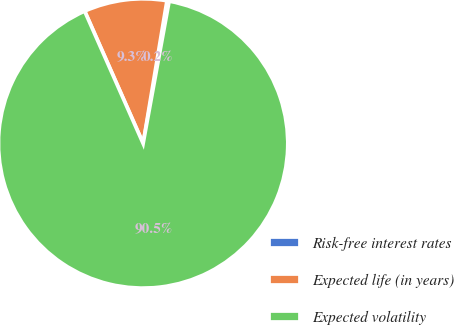Convert chart. <chart><loc_0><loc_0><loc_500><loc_500><pie_chart><fcel>Risk-free interest rates<fcel>Expected life (in years)<fcel>Expected volatility<nl><fcel>0.24%<fcel>9.26%<fcel>90.5%<nl></chart> 